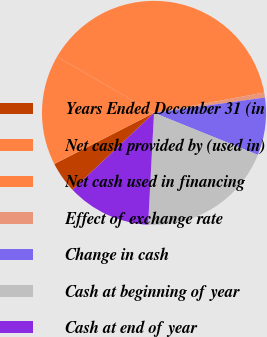<chart> <loc_0><loc_0><loc_500><loc_500><pie_chart><fcel>Years Ended December 31 (in<fcel>Net cash provided by (used in)<fcel>Net cash used in financing<fcel>Effect of exchange rate<fcel>Change in cash<fcel>Cash at beginning of year<fcel>Cash at end of year<nl><fcel>4.51%<fcel>15.91%<fcel>38.72%<fcel>0.71%<fcel>8.31%<fcel>19.72%<fcel>12.11%<nl></chart> 